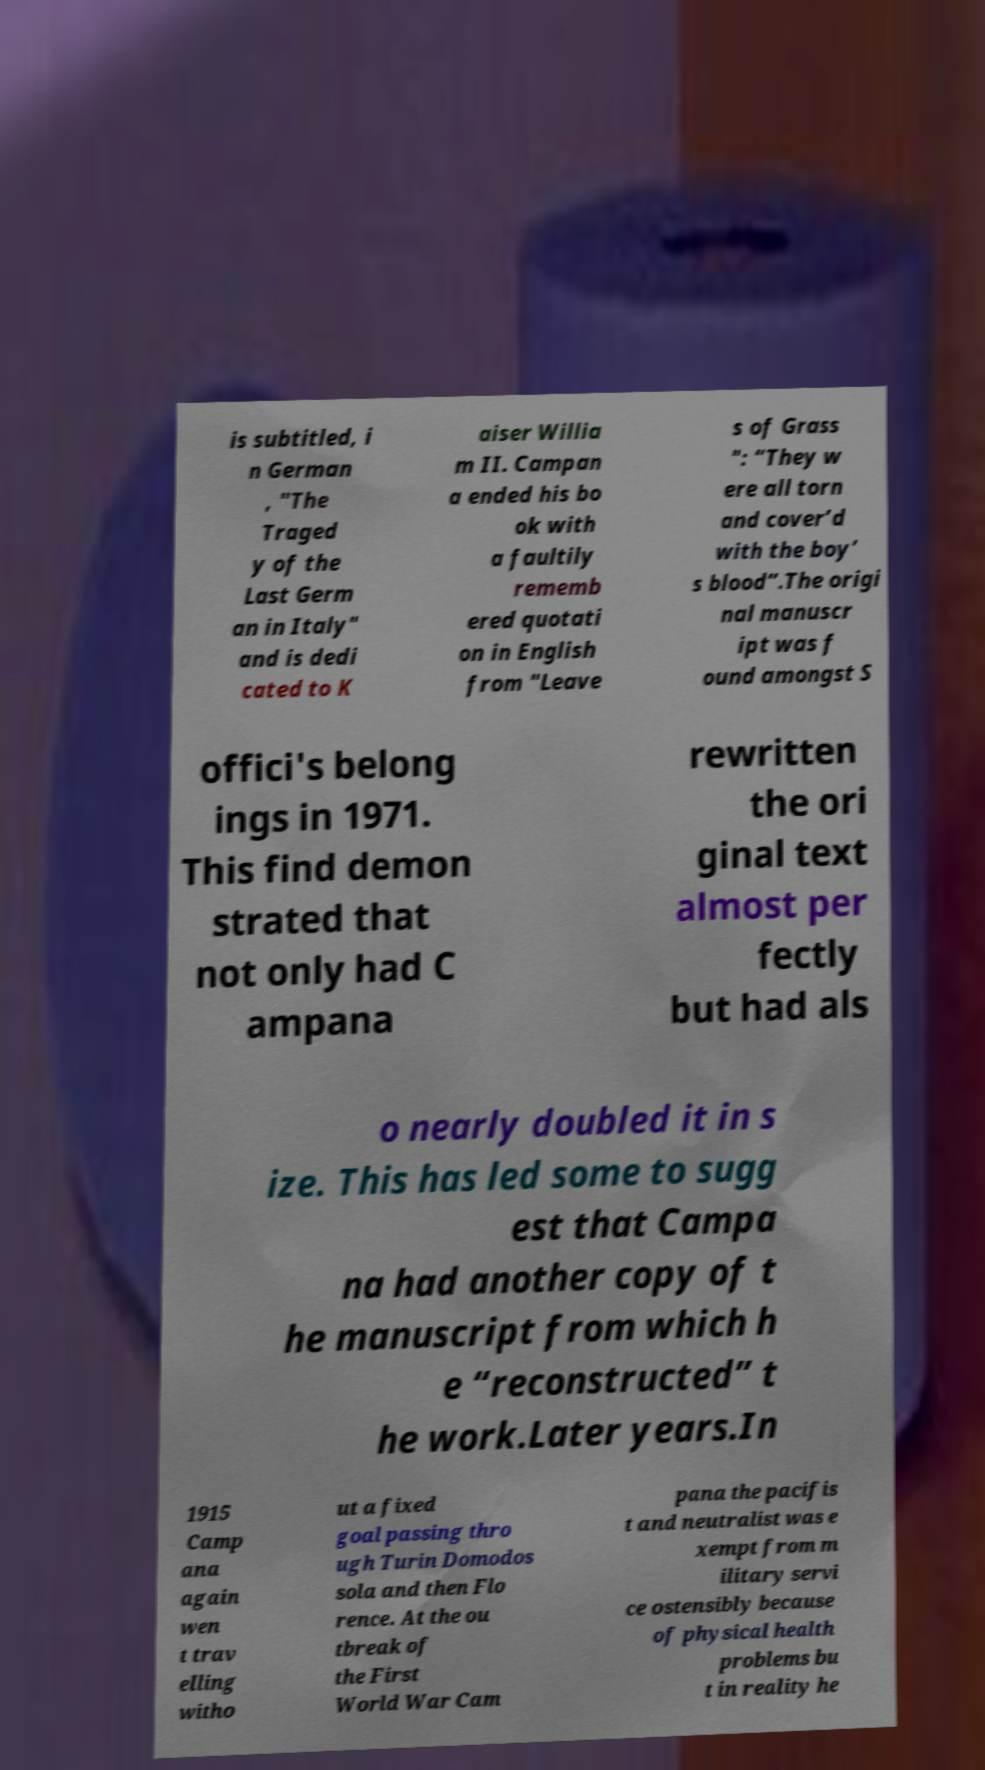Could you assist in decoding the text presented in this image and type it out clearly? is subtitled, i n German , "The Traged y of the Last Germ an in Italy" and is dedi cated to K aiser Willia m II. Campan a ended his bo ok with a faultily rememb ered quotati on in English from "Leave s of Grass ": “They w ere all torn and cover’d with the boy’ s blood”.The origi nal manuscr ipt was f ound amongst S offici's belong ings in 1971. This find demon strated that not only had C ampana rewritten the ori ginal text almost per fectly but had als o nearly doubled it in s ize. This has led some to sugg est that Campa na had another copy of t he manuscript from which h e “reconstructed” t he work.Later years.In 1915 Camp ana again wen t trav elling witho ut a fixed goal passing thro ugh Turin Domodos sola and then Flo rence. At the ou tbreak of the First World War Cam pana the pacifis t and neutralist was e xempt from m ilitary servi ce ostensibly because of physical health problems bu t in reality he 